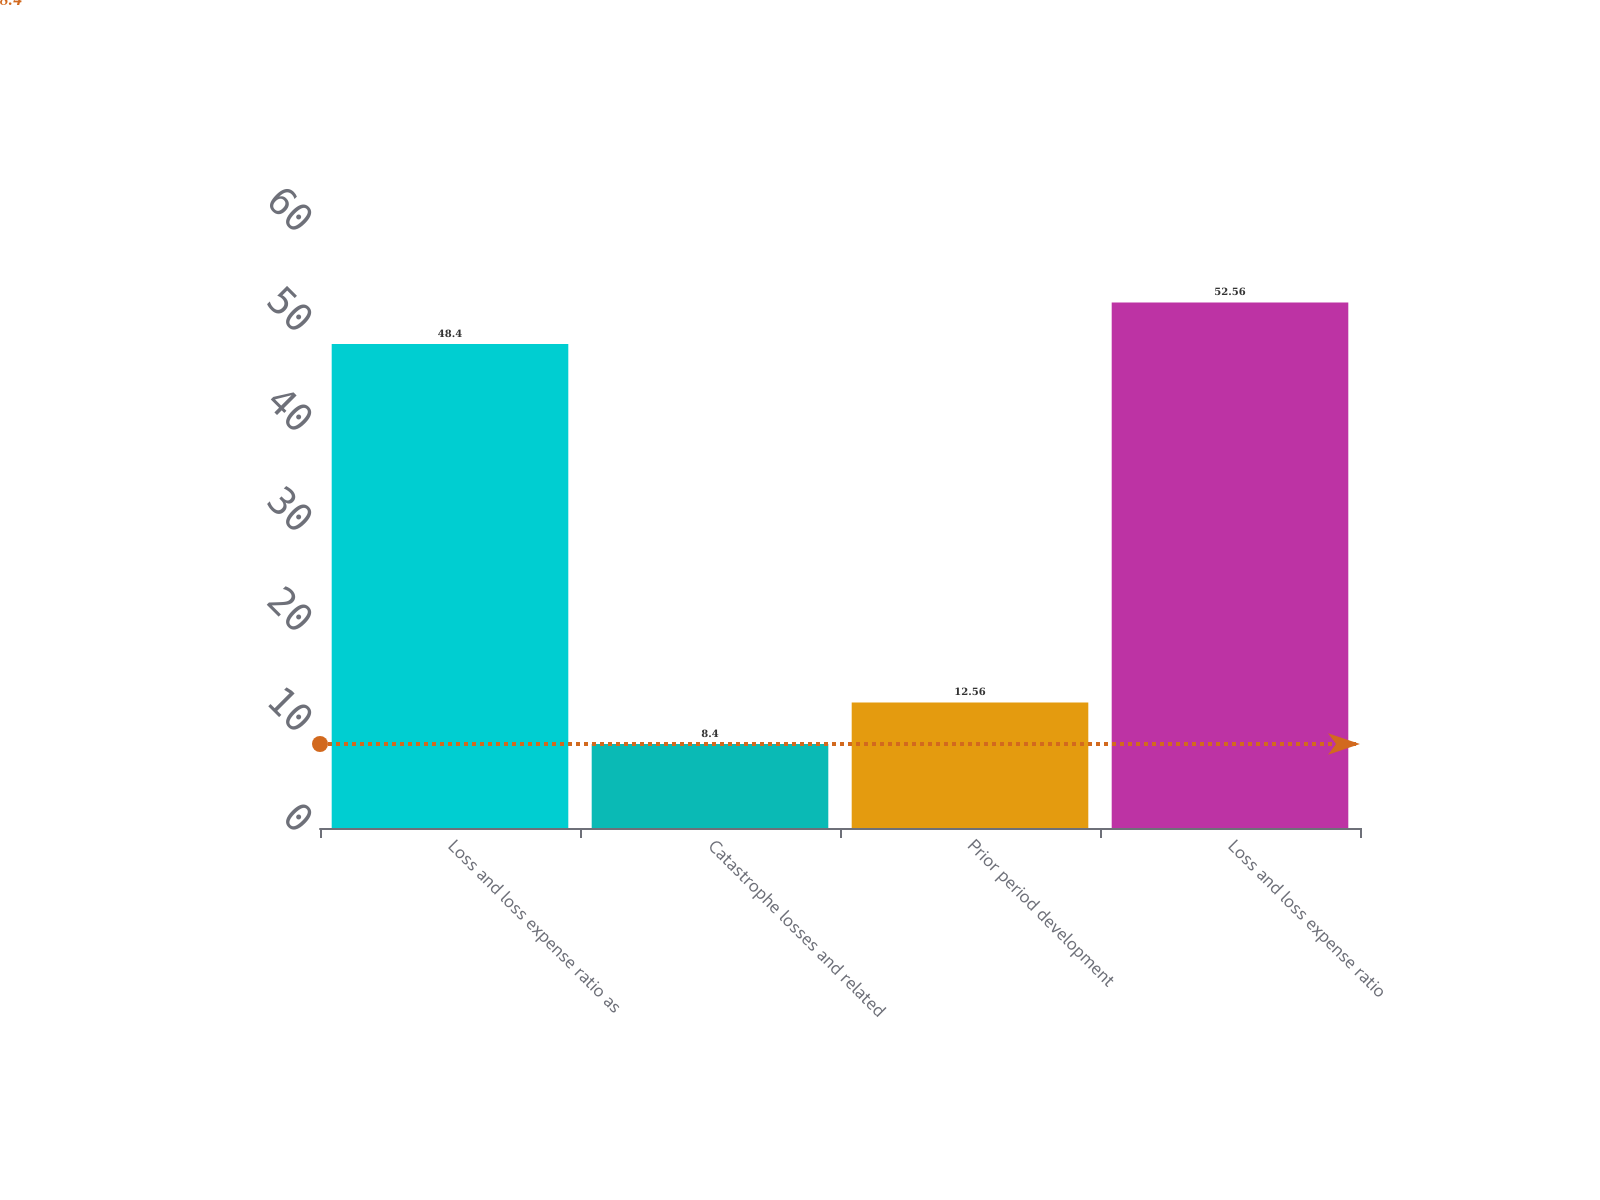Convert chart. <chart><loc_0><loc_0><loc_500><loc_500><bar_chart><fcel>Loss and loss expense ratio as<fcel>Catastrophe losses and related<fcel>Prior period development<fcel>Loss and loss expense ratio<nl><fcel>48.4<fcel>8.4<fcel>12.56<fcel>52.56<nl></chart> 